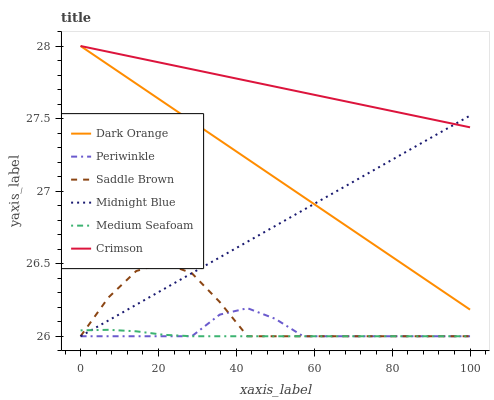Does Medium Seafoam have the minimum area under the curve?
Answer yes or no. Yes. Does Crimson have the maximum area under the curve?
Answer yes or no. Yes. Does Midnight Blue have the minimum area under the curve?
Answer yes or no. No. Does Midnight Blue have the maximum area under the curve?
Answer yes or no. No. Is Dark Orange the smoothest?
Answer yes or no. Yes. Is Saddle Brown the roughest?
Answer yes or no. Yes. Is Midnight Blue the smoothest?
Answer yes or no. No. Is Midnight Blue the roughest?
Answer yes or no. No. Does Midnight Blue have the lowest value?
Answer yes or no. Yes. Does Crimson have the lowest value?
Answer yes or no. No. Does Crimson have the highest value?
Answer yes or no. Yes. Does Midnight Blue have the highest value?
Answer yes or no. No. Is Periwinkle less than Crimson?
Answer yes or no. Yes. Is Crimson greater than Medium Seafoam?
Answer yes or no. Yes. Does Medium Seafoam intersect Saddle Brown?
Answer yes or no. Yes. Is Medium Seafoam less than Saddle Brown?
Answer yes or no. No. Is Medium Seafoam greater than Saddle Brown?
Answer yes or no. No. Does Periwinkle intersect Crimson?
Answer yes or no. No. 